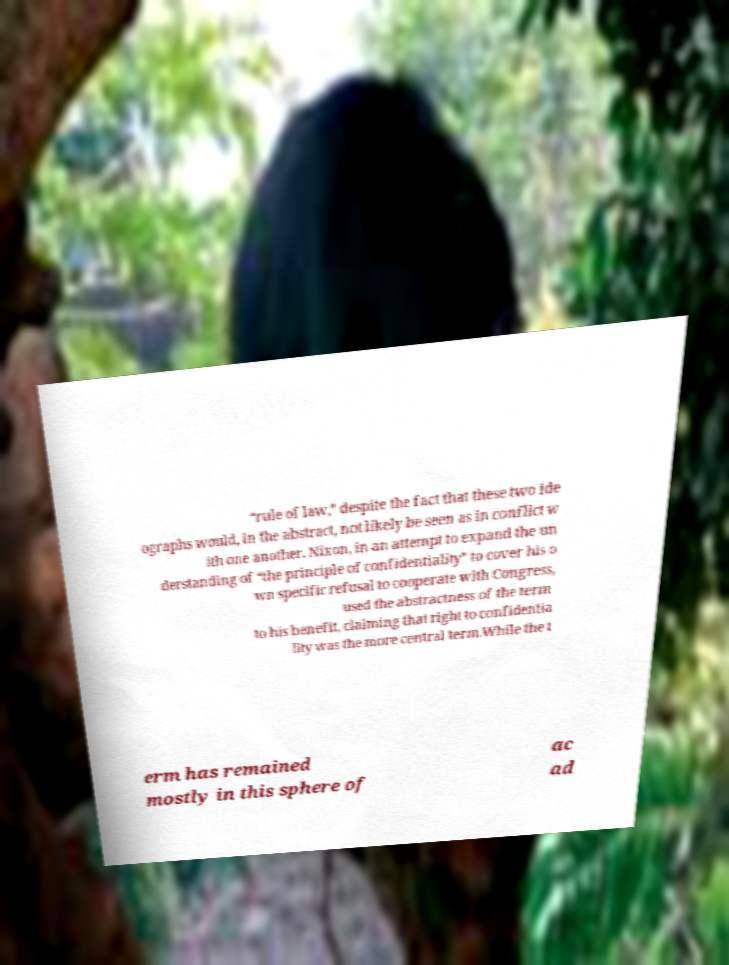For documentation purposes, I need the text within this image transcribed. Could you provide that? “rule of law,” despite the fact that these two ide ographs would, in the abstract, not likely be seen as in conflict w ith one another. Nixon, in an attempt to expand the un derstanding of “the principle of confidentiality” to cover his o wn specific refusal to cooperate with Congress, used the abstractness of the term to his benefit, claiming that right to confidentia lity was the more central term.While the t erm has remained mostly in this sphere of ac ad 